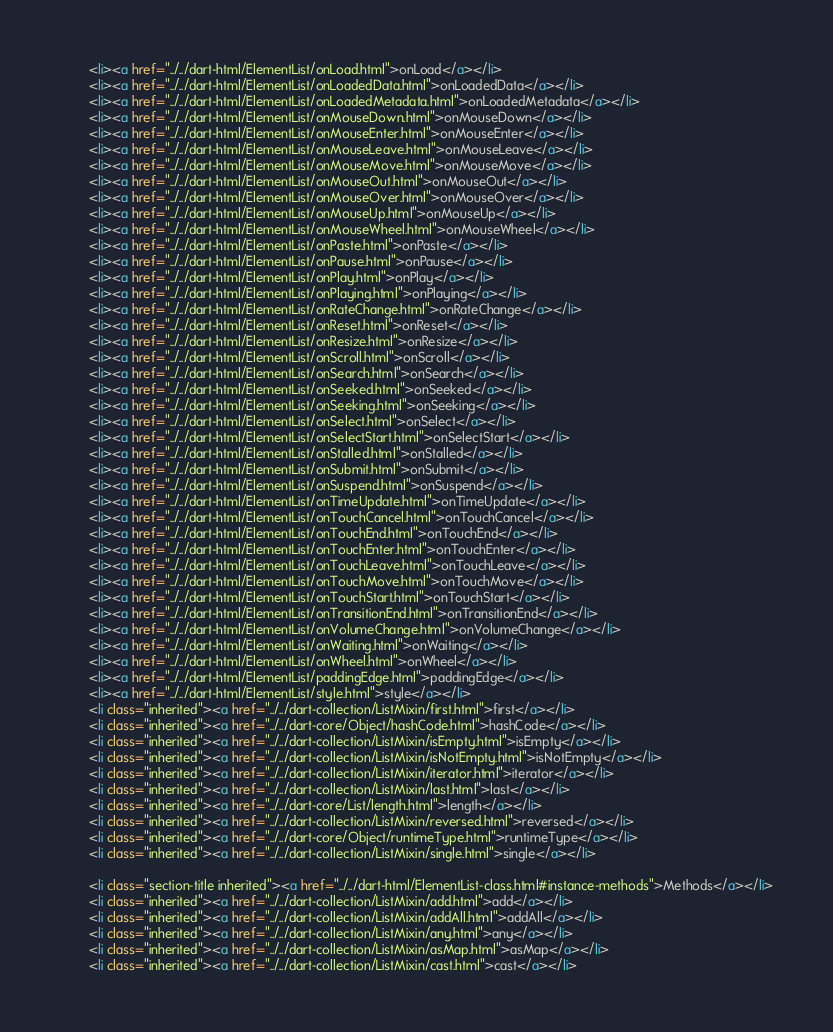Convert code to text. <code><loc_0><loc_0><loc_500><loc_500><_HTML_>        <li><a href="../../dart-html/ElementList/onLoad.html">onLoad</a></li>
        <li><a href="../../dart-html/ElementList/onLoadedData.html">onLoadedData</a></li>
        <li><a href="../../dart-html/ElementList/onLoadedMetadata.html">onLoadedMetadata</a></li>
        <li><a href="../../dart-html/ElementList/onMouseDown.html">onMouseDown</a></li>
        <li><a href="../../dart-html/ElementList/onMouseEnter.html">onMouseEnter</a></li>
        <li><a href="../../dart-html/ElementList/onMouseLeave.html">onMouseLeave</a></li>
        <li><a href="../../dart-html/ElementList/onMouseMove.html">onMouseMove</a></li>
        <li><a href="../../dart-html/ElementList/onMouseOut.html">onMouseOut</a></li>
        <li><a href="../../dart-html/ElementList/onMouseOver.html">onMouseOver</a></li>
        <li><a href="../../dart-html/ElementList/onMouseUp.html">onMouseUp</a></li>
        <li><a href="../../dart-html/ElementList/onMouseWheel.html">onMouseWheel</a></li>
        <li><a href="../../dart-html/ElementList/onPaste.html">onPaste</a></li>
        <li><a href="../../dart-html/ElementList/onPause.html">onPause</a></li>
        <li><a href="../../dart-html/ElementList/onPlay.html">onPlay</a></li>
        <li><a href="../../dart-html/ElementList/onPlaying.html">onPlaying</a></li>
        <li><a href="../../dart-html/ElementList/onRateChange.html">onRateChange</a></li>
        <li><a href="../../dart-html/ElementList/onReset.html">onReset</a></li>
        <li><a href="../../dart-html/ElementList/onResize.html">onResize</a></li>
        <li><a href="../../dart-html/ElementList/onScroll.html">onScroll</a></li>
        <li><a href="../../dart-html/ElementList/onSearch.html">onSearch</a></li>
        <li><a href="../../dart-html/ElementList/onSeeked.html">onSeeked</a></li>
        <li><a href="../../dart-html/ElementList/onSeeking.html">onSeeking</a></li>
        <li><a href="../../dart-html/ElementList/onSelect.html">onSelect</a></li>
        <li><a href="../../dart-html/ElementList/onSelectStart.html">onSelectStart</a></li>
        <li><a href="../../dart-html/ElementList/onStalled.html">onStalled</a></li>
        <li><a href="../../dart-html/ElementList/onSubmit.html">onSubmit</a></li>
        <li><a href="../../dart-html/ElementList/onSuspend.html">onSuspend</a></li>
        <li><a href="../../dart-html/ElementList/onTimeUpdate.html">onTimeUpdate</a></li>
        <li><a href="../../dart-html/ElementList/onTouchCancel.html">onTouchCancel</a></li>
        <li><a href="../../dart-html/ElementList/onTouchEnd.html">onTouchEnd</a></li>
        <li><a href="../../dart-html/ElementList/onTouchEnter.html">onTouchEnter</a></li>
        <li><a href="../../dart-html/ElementList/onTouchLeave.html">onTouchLeave</a></li>
        <li><a href="../../dart-html/ElementList/onTouchMove.html">onTouchMove</a></li>
        <li><a href="../../dart-html/ElementList/onTouchStart.html">onTouchStart</a></li>
        <li><a href="../../dart-html/ElementList/onTransitionEnd.html">onTransitionEnd</a></li>
        <li><a href="../../dart-html/ElementList/onVolumeChange.html">onVolumeChange</a></li>
        <li><a href="../../dart-html/ElementList/onWaiting.html">onWaiting</a></li>
        <li><a href="../../dart-html/ElementList/onWheel.html">onWheel</a></li>
        <li><a href="../../dart-html/ElementList/paddingEdge.html">paddingEdge</a></li>
        <li><a href="../../dart-html/ElementList/style.html">style</a></li>
        <li class="inherited"><a href="../../dart-collection/ListMixin/first.html">first</a></li>
        <li class="inherited"><a href="../../dart-core/Object/hashCode.html">hashCode</a></li>
        <li class="inherited"><a href="../../dart-collection/ListMixin/isEmpty.html">isEmpty</a></li>
        <li class="inherited"><a href="../../dart-collection/ListMixin/isNotEmpty.html">isNotEmpty</a></li>
        <li class="inherited"><a href="../../dart-collection/ListMixin/iterator.html">iterator</a></li>
        <li class="inherited"><a href="../../dart-collection/ListMixin/last.html">last</a></li>
        <li class="inherited"><a href="../../dart-core/List/length.html">length</a></li>
        <li class="inherited"><a href="../../dart-collection/ListMixin/reversed.html">reversed</a></li>
        <li class="inherited"><a href="../../dart-core/Object/runtimeType.html">runtimeType</a></li>
        <li class="inherited"><a href="../../dart-collection/ListMixin/single.html">single</a></li>
    
        <li class="section-title inherited"><a href="../../dart-html/ElementList-class.html#instance-methods">Methods</a></li>
        <li class="inherited"><a href="../../dart-collection/ListMixin/add.html">add</a></li>
        <li class="inherited"><a href="../../dart-collection/ListMixin/addAll.html">addAll</a></li>
        <li class="inherited"><a href="../../dart-collection/ListMixin/any.html">any</a></li>
        <li class="inherited"><a href="../../dart-collection/ListMixin/asMap.html">asMap</a></li>
        <li class="inherited"><a href="../../dart-collection/ListMixin/cast.html">cast</a></li></code> 